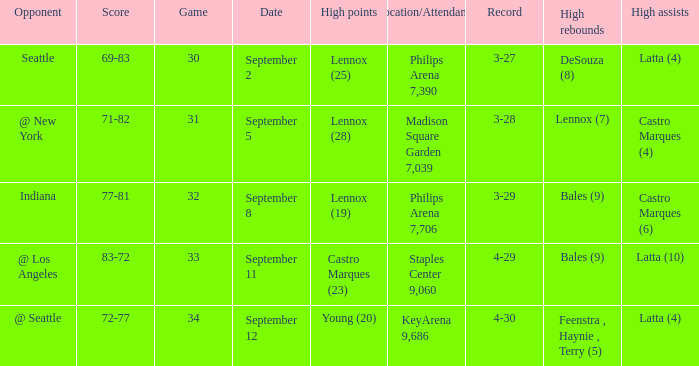What was the Location/Attendance on september 11? Staples Center 9,060. 